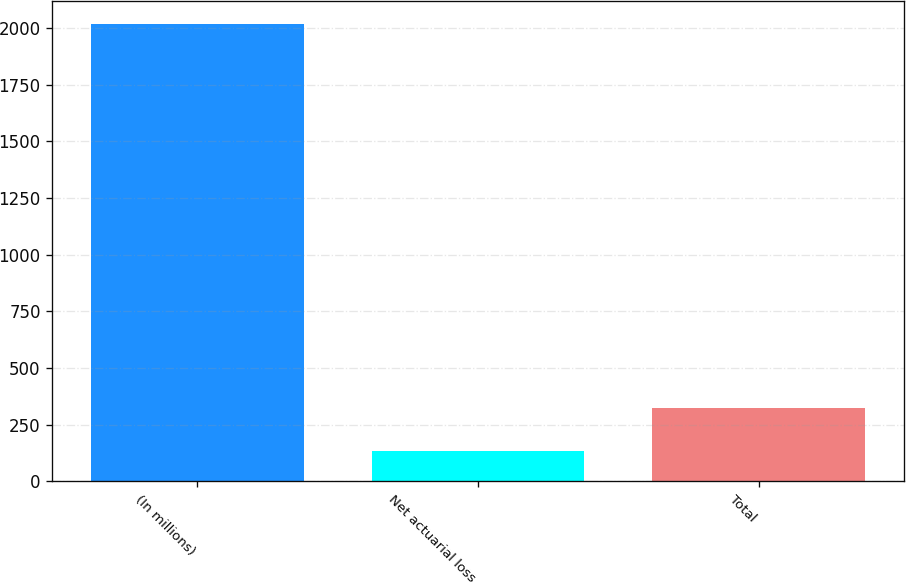Convert chart. <chart><loc_0><loc_0><loc_500><loc_500><bar_chart><fcel>(In millions)<fcel>Net actuarial loss<fcel>Total<nl><fcel>2018<fcel>134<fcel>322.4<nl></chart> 